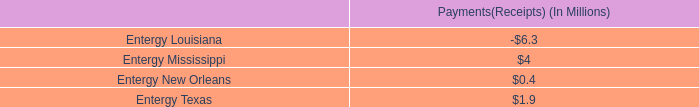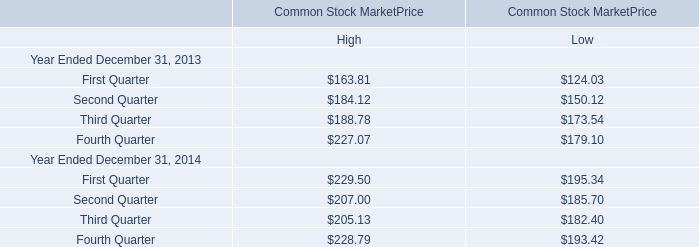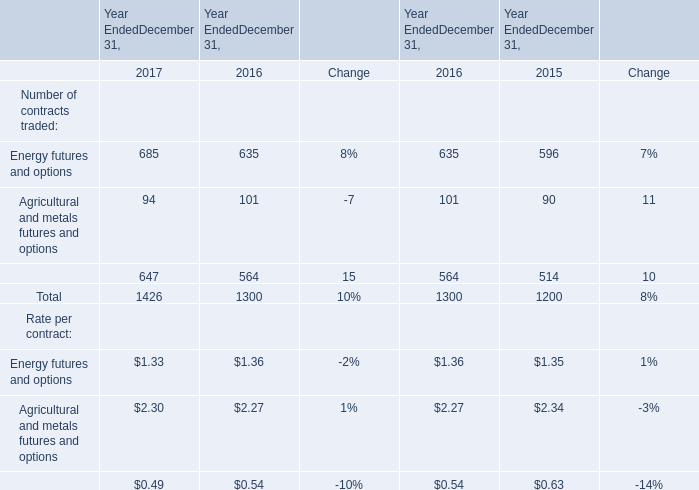What's the growth rate of Total Number of contracts traded in 2017? (in %) 
Answer: 10. 